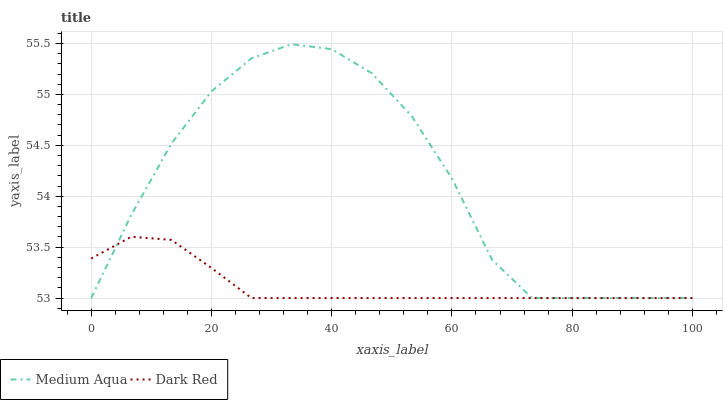Does Medium Aqua have the minimum area under the curve?
Answer yes or no. No. Is Medium Aqua the smoothest?
Answer yes or no. No. 